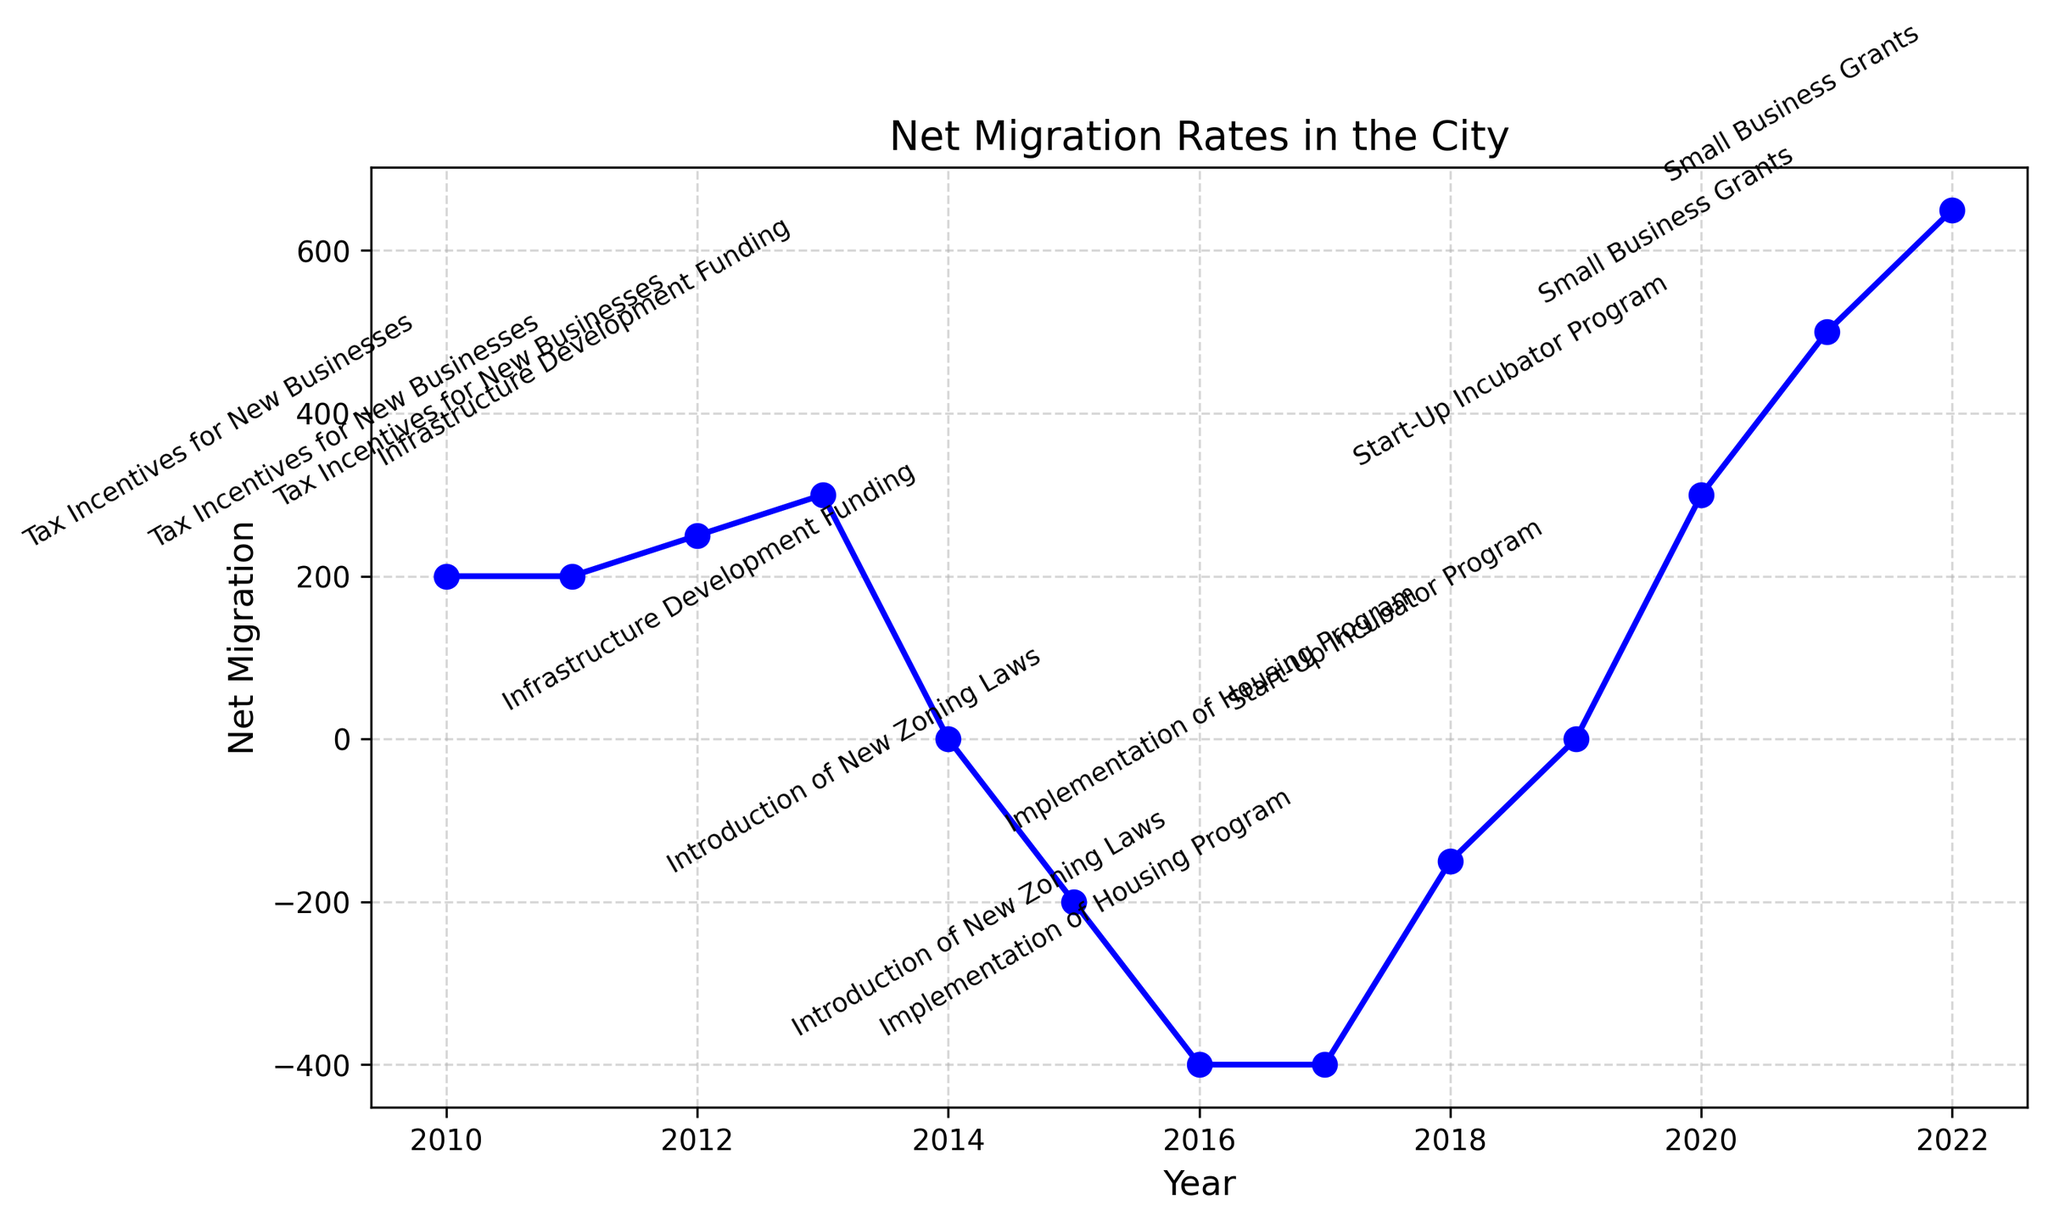How did the net migration change between 2010 and 2016? To find the change in net migration between 2010 and 2016, subtract the net migration value of 2010 (200) from the net migration value of 2016 (-400). 2016 net migration is -400 and 2010 net migration is 200. So, -400 - 200 gives a change of -600.
Answer: -600 Which year saw the highest net migration? By examining the plot, the highest point on the net migration line is in 2022 with a value of 650.
Answer: 2022 What economic policy change was associated with the highest net migration increase? The text annotation for the highest point (2022) on the net migration curve indicates "Small Business Grants."
Answer: Small Business Grants For which policy changes was the net migration negative? Net migration was negative in the years 2015 and 2016 (Introduction of New Zoning Laws) and also in 2017 and 2018 (Implementation of Housing Program).
Answer: Introduction of New Zoning Laws, Implementation of Housing Program By how much did the net migration rate change from the Introduction of New Zoning Laws policy period to the Small Business Grants policy period? Net migration during the Introduction of New Zoning Laws policy period ranged from -200 to -400. For the Small Business Grants policy period, net migration ranged from 500 to 650. Taking the final years, the change is from -400 (2016) to 650 (2022), calculated as 650 - (-400) = 1050.
Answer: 1050 Did any economic policy result in a net-zero migration rate during its implementation? Looking at the visual plot, the net migration rate was zero in 2014 (Infrastructure Development Funding) and 2019 (Start-Up Incubator Program).
Answer: Yes, Infrastructure Development Funding and Start-Up Incubator Program Which period had the largest decline in net migration and how much was it? The largest decline in net migration occurred between 2014 (0) to 2015 (-200). The difference is 0 - (-200) = 200.
Answer: 200 